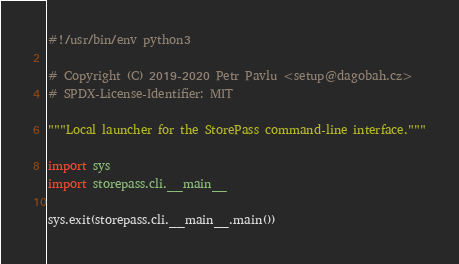<code> <loc_0><loc_0><loc_500><loc_500><_Python_>#!/usr/bin/env python3

# Copyright (C) 2019-2020 Petr Pavlu <setup@dagobah.cz>
# SPDX-License-Identifier: MIT

"""Local launcher for the StorePass command-line interface."""

import sys
import storepass.cli.__main__

sys.exit(storepass.cli.__main__.main())
</code> 